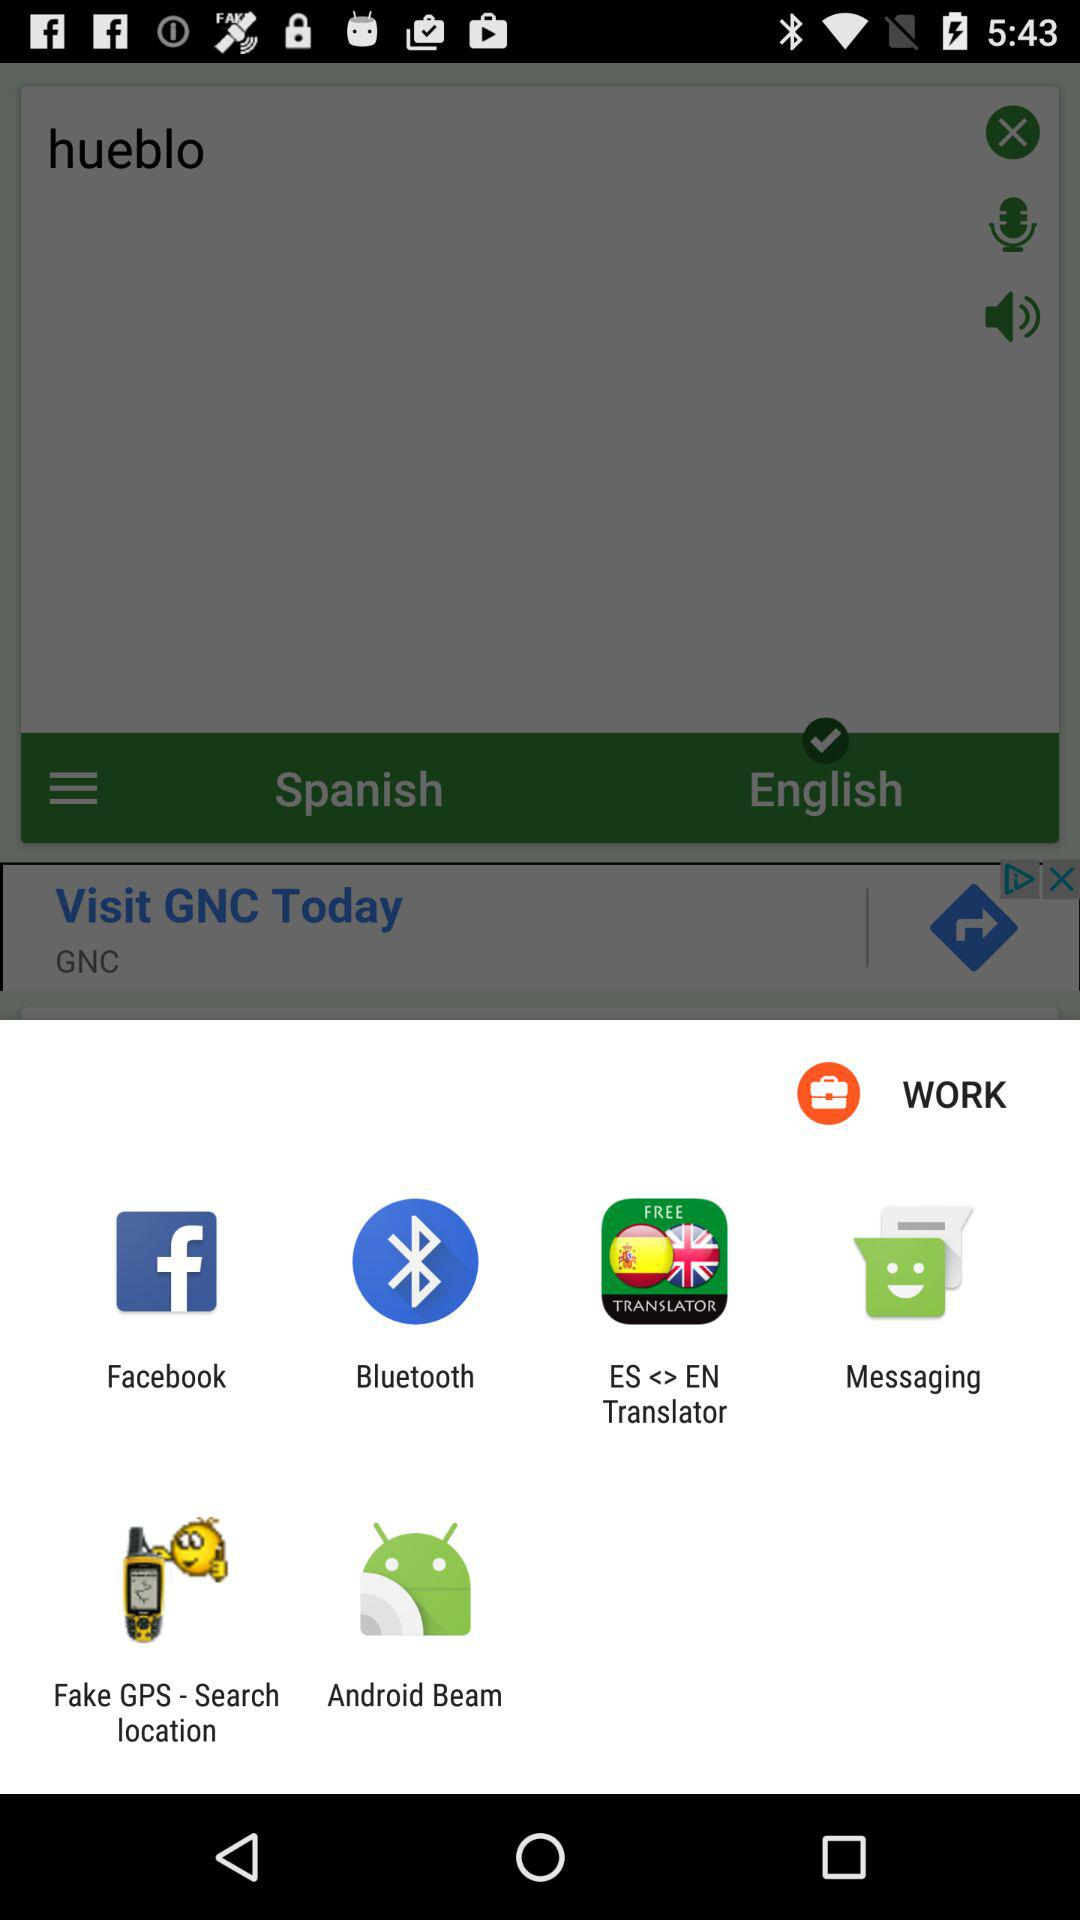What is the username?
When the provided information is insufficient, respond with <no answer>. <no answer> 